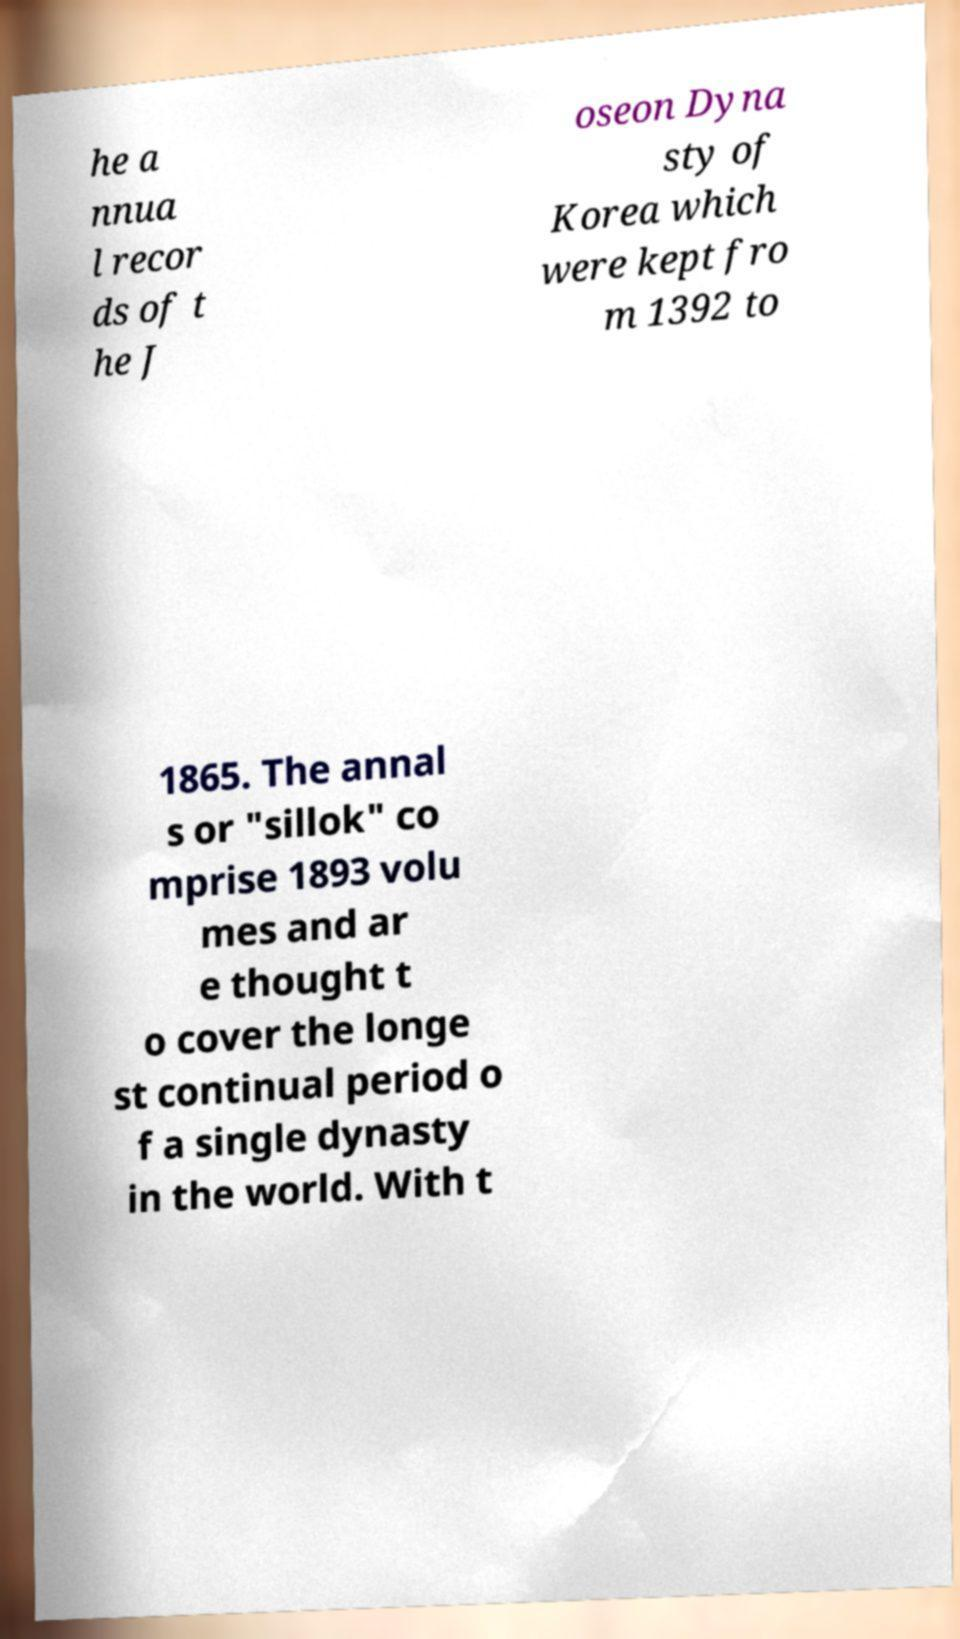Can you accurately transcribe the text from the provided image for me? he a nnua l recor ds of t he J oseon Dyna sty of Korea which were kept fro m 1392 to 1865. The annal s or "sillok" co mprise 1893 volu mes and ar e thought t o cover the longe st continual period o f a single dynasty in the world. With t 